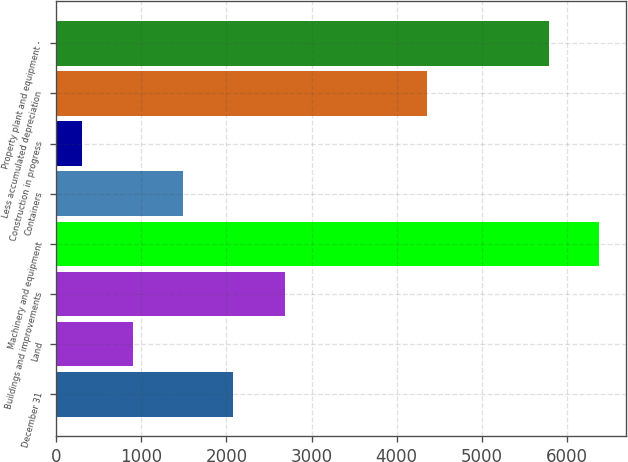Convert chart to OTSL. <chart><loc_0><loc_0><loc_500><loc_500><bar_chart><fcel>December 31<fcel>Land<fcel>Buildings and improvements<fcel>Machinery and equipment<fcel>Containers<fcel>Construction in progress<fcel>Less accumulated depreciation<fcel>Property plant and equipment -<nl><fcel>2082<fcel>898<fcel>2692<fcel>6378<fcel>1490<fcel>306<fcel>4353<fcel>5786<nl></chart> 